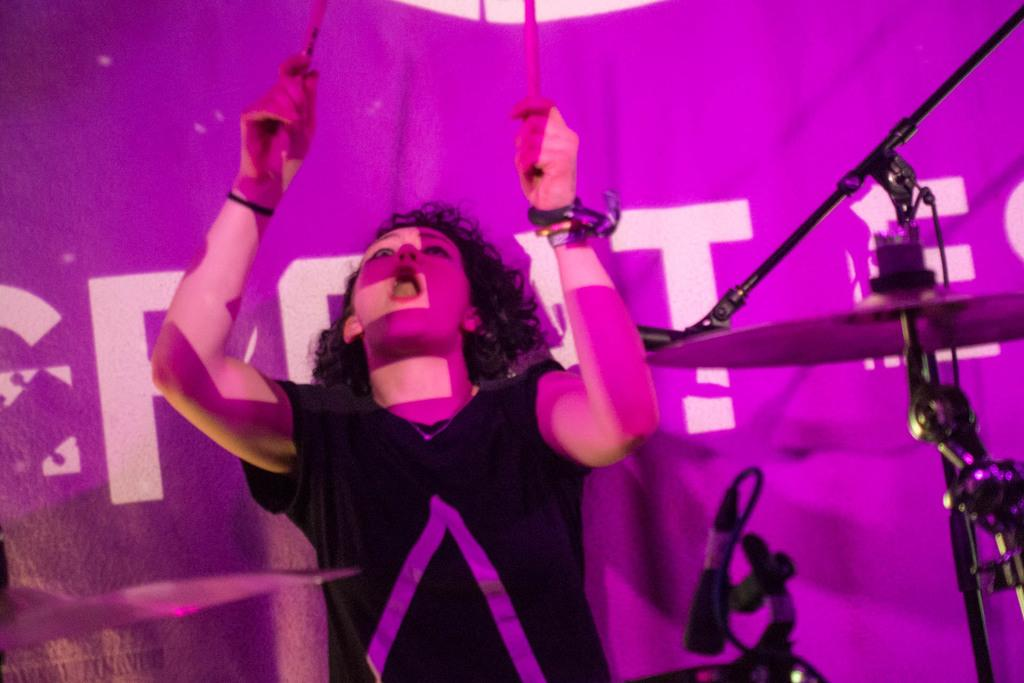Who is the main subject in the image? There is a girl in the center of the image. What is the girl holding in her hands? The girl is holding sticks in her hands. What can be seen in the background of the image? There is a flex in the background of the image. What type of riddle is the girl trying to solve in the image? There is no riddle present in the image; the girl is simply holding sticks in her hands. How many chairs can be seen in the image? There are no chairs present in the image. 